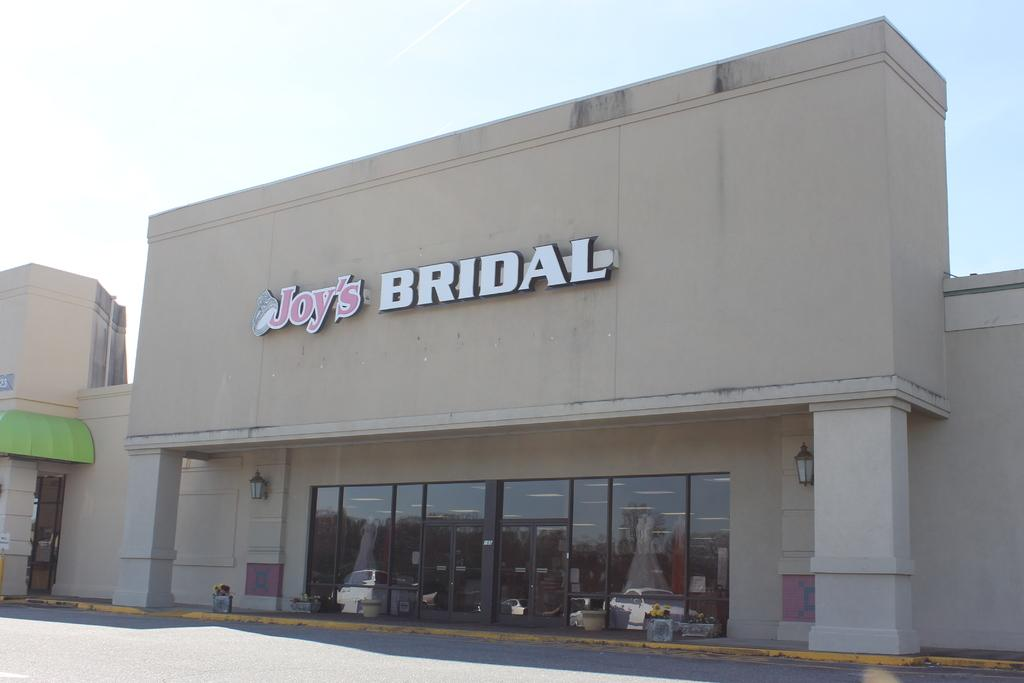What type of structure is present in the image? There is a building in the image. What can be seen on the building? There is text on the building. What is visible at the top of the image? The sky is visible at the top of the image. What is visible at the bottom of the image? There is a road visible at the bottom of the image. How many brothers are standing on the card in the image? There is no card or brothers present in the image. 